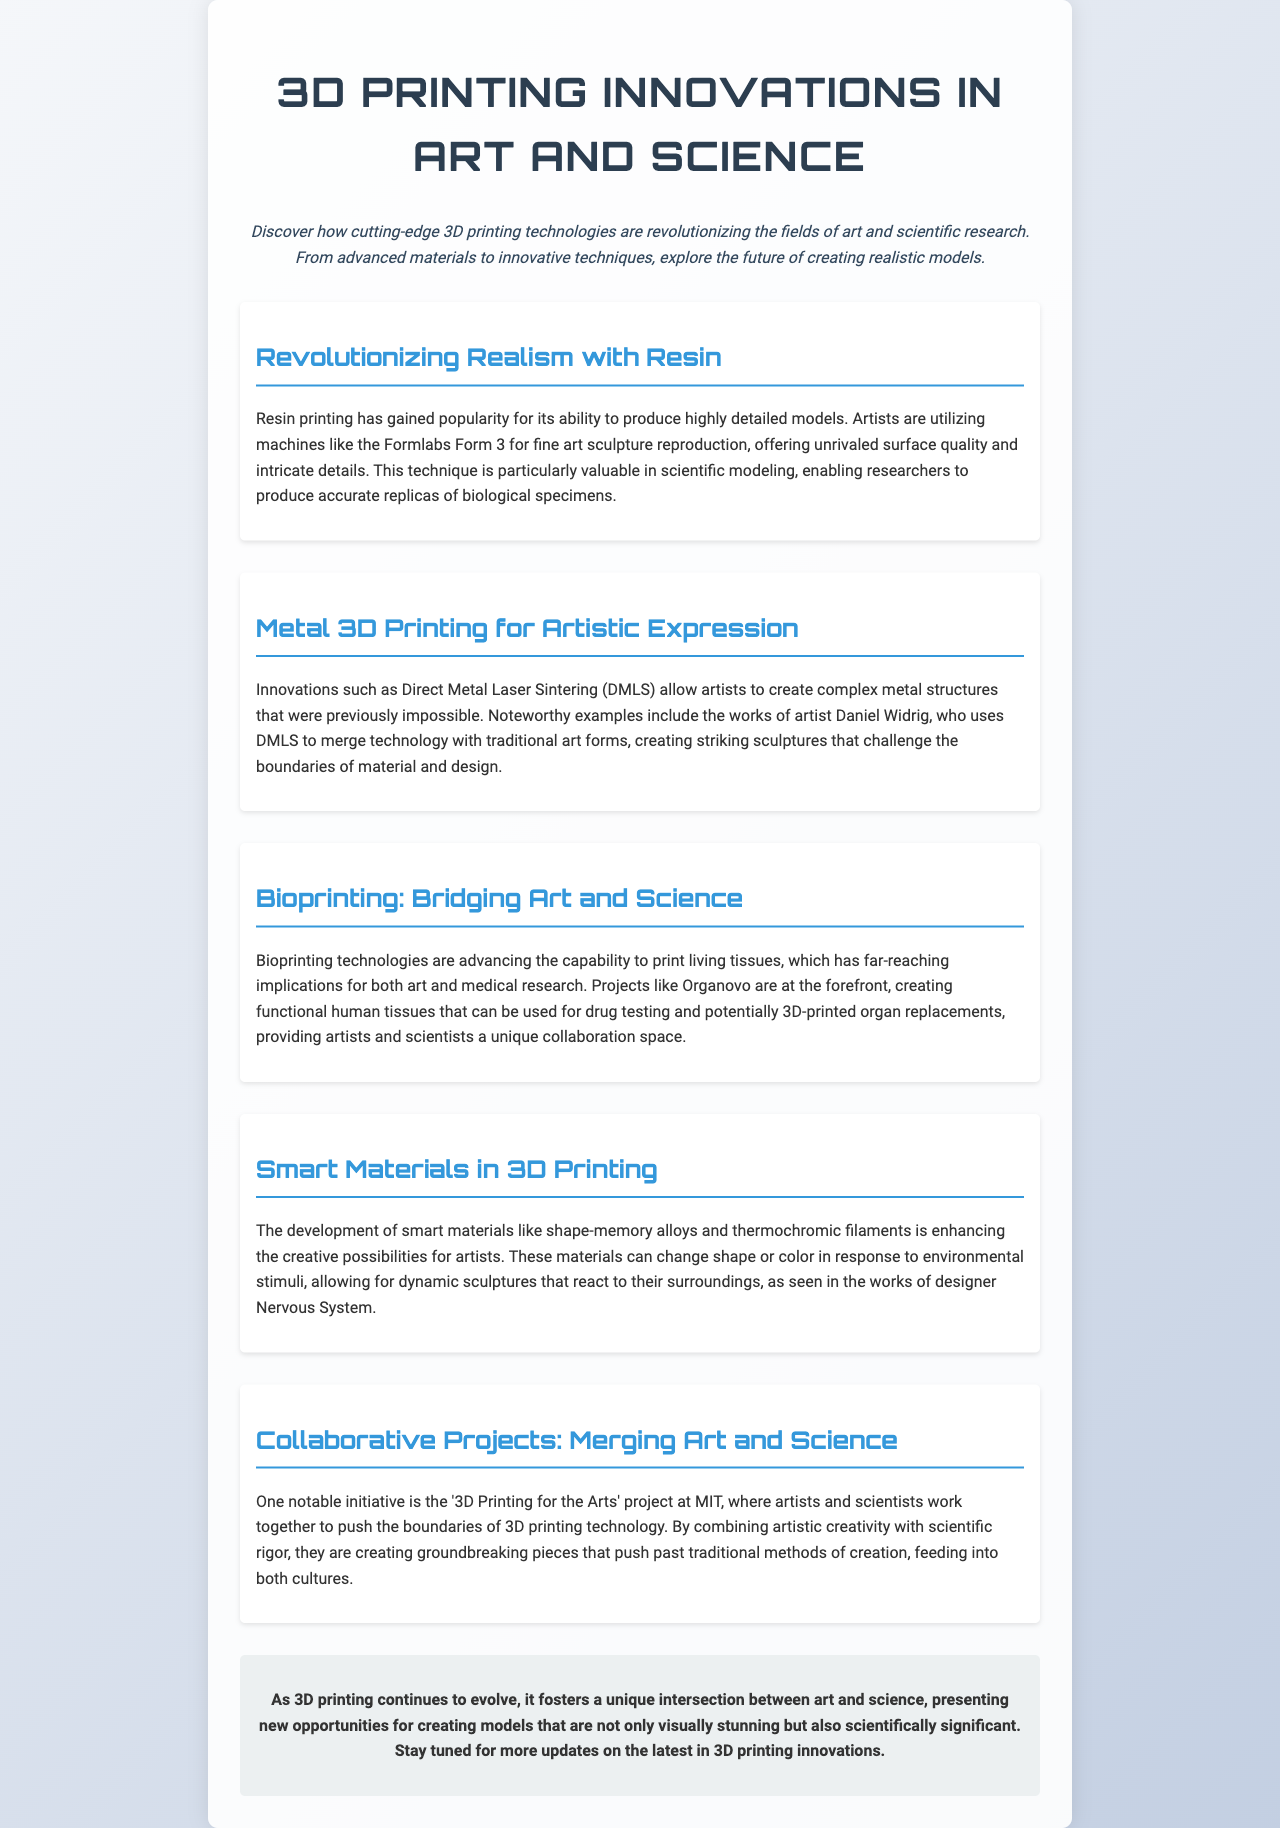What 3D printing technique is popular for fine art sculpture reproduction? The document mentions resin printing as a popular technique for producing highly detailed models, particularly in fine art sculpture reproduction.
Answer: Resin printing Who is the artist noted for using Direct Metal Laser Sintering? The document names Daniel Widrig as the artist who uses Direct Metal Laser Sintering to create complex metal structures.
Answer: Daniel Widrig What is the name of the project at MIT that merges art and science? The document refers to the initiative as the '3D Printing for the Arts' project at MIT, where artists and scientists collaborate.
Answer: 3D Printing for the Arts What is one application of bioprinting mentioned? The document states that bioprinting technologies create functional human tissues that can be used for drug testing.
Answer: Drug testing Which smart material is mentioned in relation to changing shape or color? The document refers to shape-memory alloys and thermochromic filaments as examples of smart materials that enhance creative possibilities.
Answer: Smart materials What major theme is explored in this newsletter? The newsletter discusses how 3D printing technologies are revolutionizing art and scientific research, emphasizing the intersection of both fields.
Answer: Intersection of art and science How many sections are included in the newsletter? The newsletter contains five sections that focus on various innovations in 3D printing related to art and science.
Answer: Five sections 